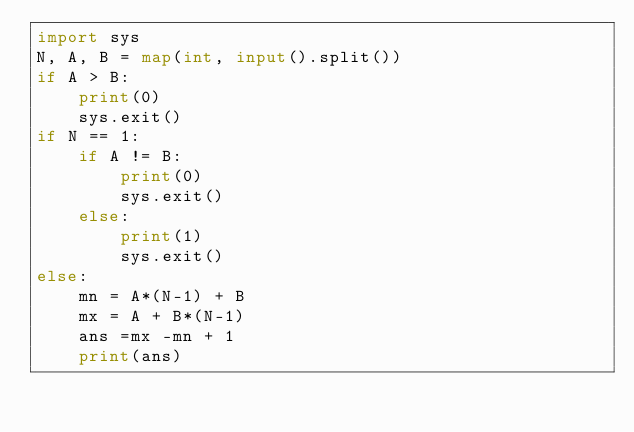Convert code to text. <code><loc_0><loc_0><loc_500><loc_500><_Python_>import sys
N, A, B = map(int, input().split())
if A > B:
    print(0)
    sys.exit()
if N == 1:
    if A != B:
        print(0)
        sys.exit()
    else:
        print(1)
        sys.exit()
else:
    mn = A*(N-1) + B
    mx = A + B*(N-1)
    ans =mx -mn + 1
    print(ans)
</code> 